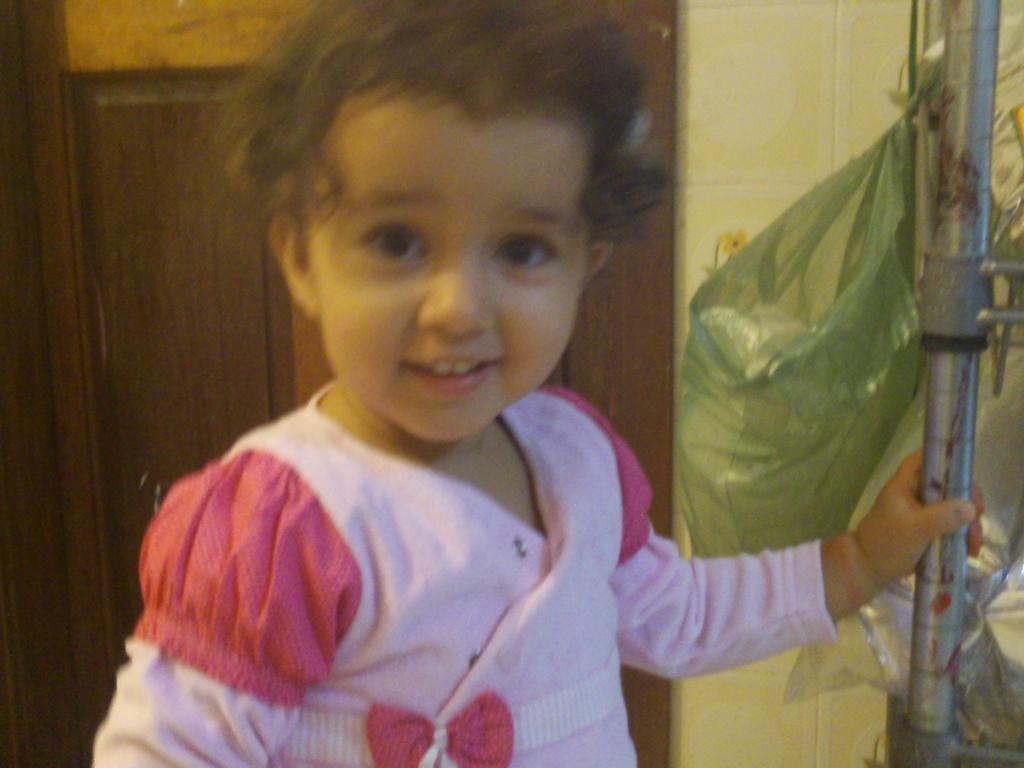Could you give a brief overview of what you see in this image? In the foreground I can see a kid is holding a metal rod in hand. In the background I can see a door, cover and a wall. This image is taken, may be in a room. 